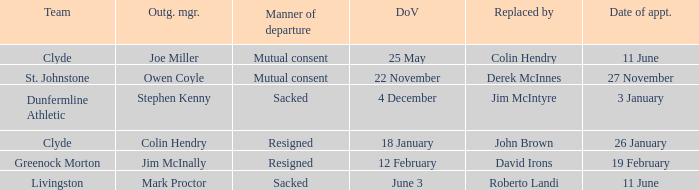I want to know the team that was sacked and date of vacancy was 4 december Dunfermline Athletic. 